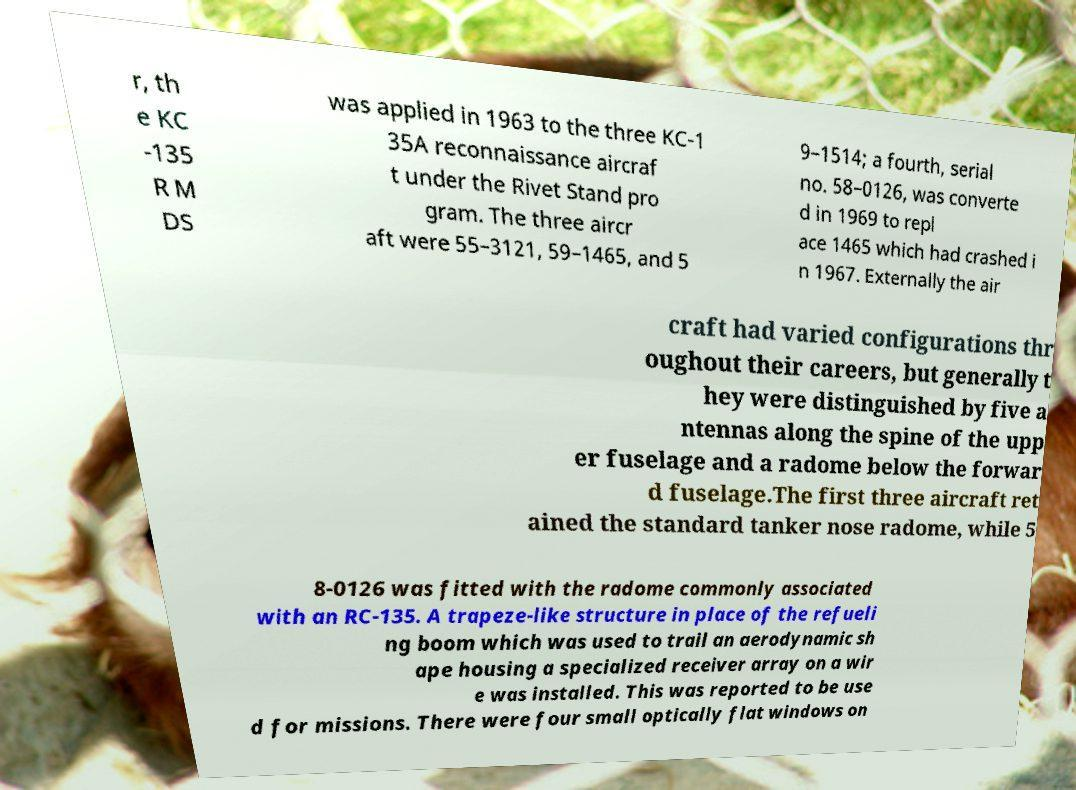There's text embedded in this image that I need extracted. Can you transcribe it verbatim? r, th e KC -135 R M DS was applied in 1963 to the three KC-1 35A reconnaissance aircraf t under the Rivet Stand pro gram. The three aircr aft were 55–3121, 59–1465, and 5 9–1514; a fourth, serial no. 58–0126, was converte d in 1969 to repl ace 1465 which had crashed i n 1967. Externally the air craft had varied configurations thr oughout their careers, but generally t hey were distinguished by five a ntennas along the spine of the upp er fuselage and a radome below the forwar d fuselage.The first three aircraft ret ained the standard tanker nose radome, while 5 8-0126 was fitted with the radome commonly associated with an RC-135. A trapeze-like structure in place of the refueli ng boom which was used to trail an aerodynamic sh ape housing a specialized receiver array on a wir e was installed. This was reported to be use d for missions. There were four small optically flat windows on 